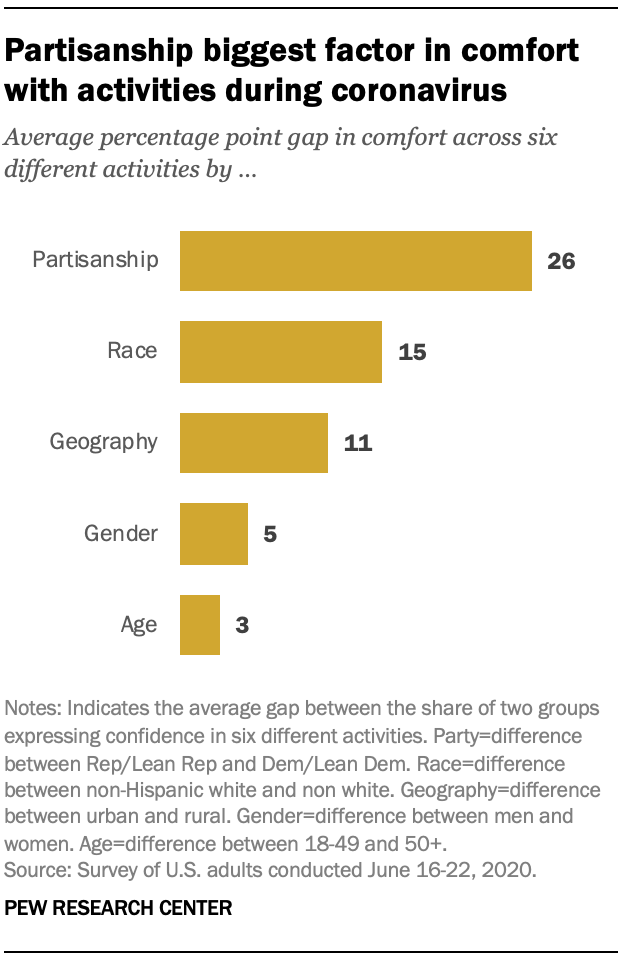Outline some significant characteristics in this image. The sum of the two smallest bars is less than the third smallest bar. The peak value of all the bars is [26,15,11,5,3]. 